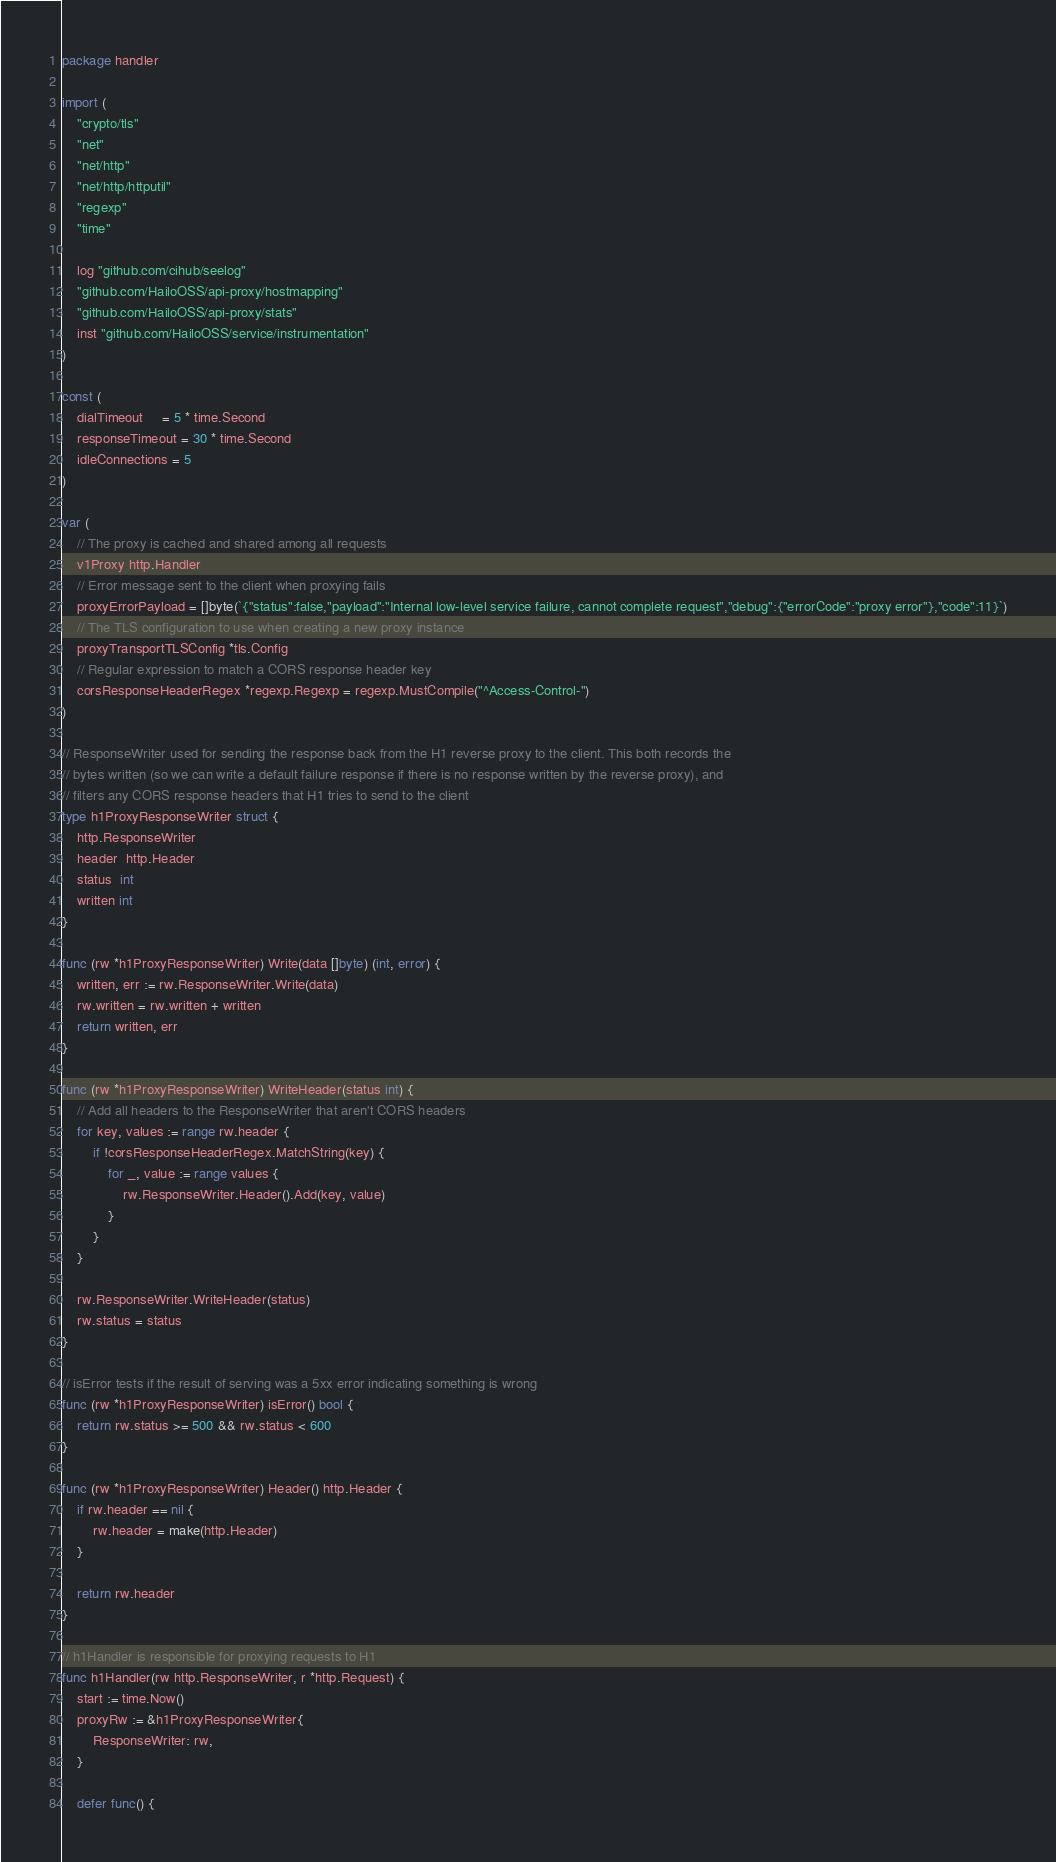Convert code to text. <code><loc_0><loc_0><loc_500><loc_500><_Go_>package handler

import (
	"crypto/tls"
	"net"
	"net/http"
	"net/http/httputil"
	"regexp"
	"time"

	log "github.com/cihub/seelog"
	"github.com/HailoOSS/api-proxy/hostmapping"
	"github.com/HailoOSS/api-proxy/stats"
	inst "github.com/HailoOSS/service/instrumentation"
)

const (
	dialTimeout     = 5 * time.Second
	responseTimeout = 30 * time.Second
	idleConnections = 5
)

var (
	// The proxy is cached and shared among all requests
	v1Proxy http.Handler
	// Error message sent to the client when proxying fails
	proxyErrorPayload = []byte(`{"status":false,"payload":"Internal low-level service failure, cannot complete request","debug":{"errorCode":"proxy error"},"code":11}`)
	// The TLS configuration to use when creating a new proxy instance
	proxyTransportTLSConfig *tls.Config
	// Regular expression to match a CORS response header key
	corsResponseHeaderRegex *regexp.Regexp = regexp.MustCompile("^Access-Control-")
)

// ResponseWriter used for sending the response back from the H1 reverse proxy to the client. This both records the
// bytes written (so we can write a default failure response if there is no response written by the reverse proxy), and
// filters any CORS response headers that H1 tries to send to the client
type h1ProxyResponseWriter struct {
	http.ResponseWriter
	header  http.Header
	status  int
	written int
}

func (rw *h1ProxyResponseWriter) Write(data []byte) (int, error) {
	written, err := rw.ResponseWriter.Write(data)
	rw.written = rw.written + written
	return written, err
}

func (rw *h1ProxyResponseWriter) WriteHeader(status int) {
	// Add all headers to the ResponseWriter that aren't CORS headers
	for key, values := range rw.header {
		if !corsResponseHeaderRegex.MatchString(key) {
			for _, value := range values {
				rw.ResponseWriter.Header().Add(key, value)
			}
		}
	}

	rw.ResponseWriter.WriteHeader(status)
	rw.status = status
}

// isError tests if the result of serving was a 5xx error indicating something is wrong
func (rw *h1ProxyResponseWriter) isError() bool {
	return rw.status >= 500 && rw.status < 600
}

func (rw *h1ProxyResponseWriter) Header() http.Header {
	if rw.header == nil {
		rw.header = make(http.Header)
	}

	return rw.header
}

// h1Handler is responsible for proxying requests to H1
func h1Handler(rw http.ResponseWriter, r *http.Request) {
	start := time.Now()
	proxyRw := &h1ProxyResponseWriter{
		ResponseWriter: rw,
	}

	defer func() {</code> 